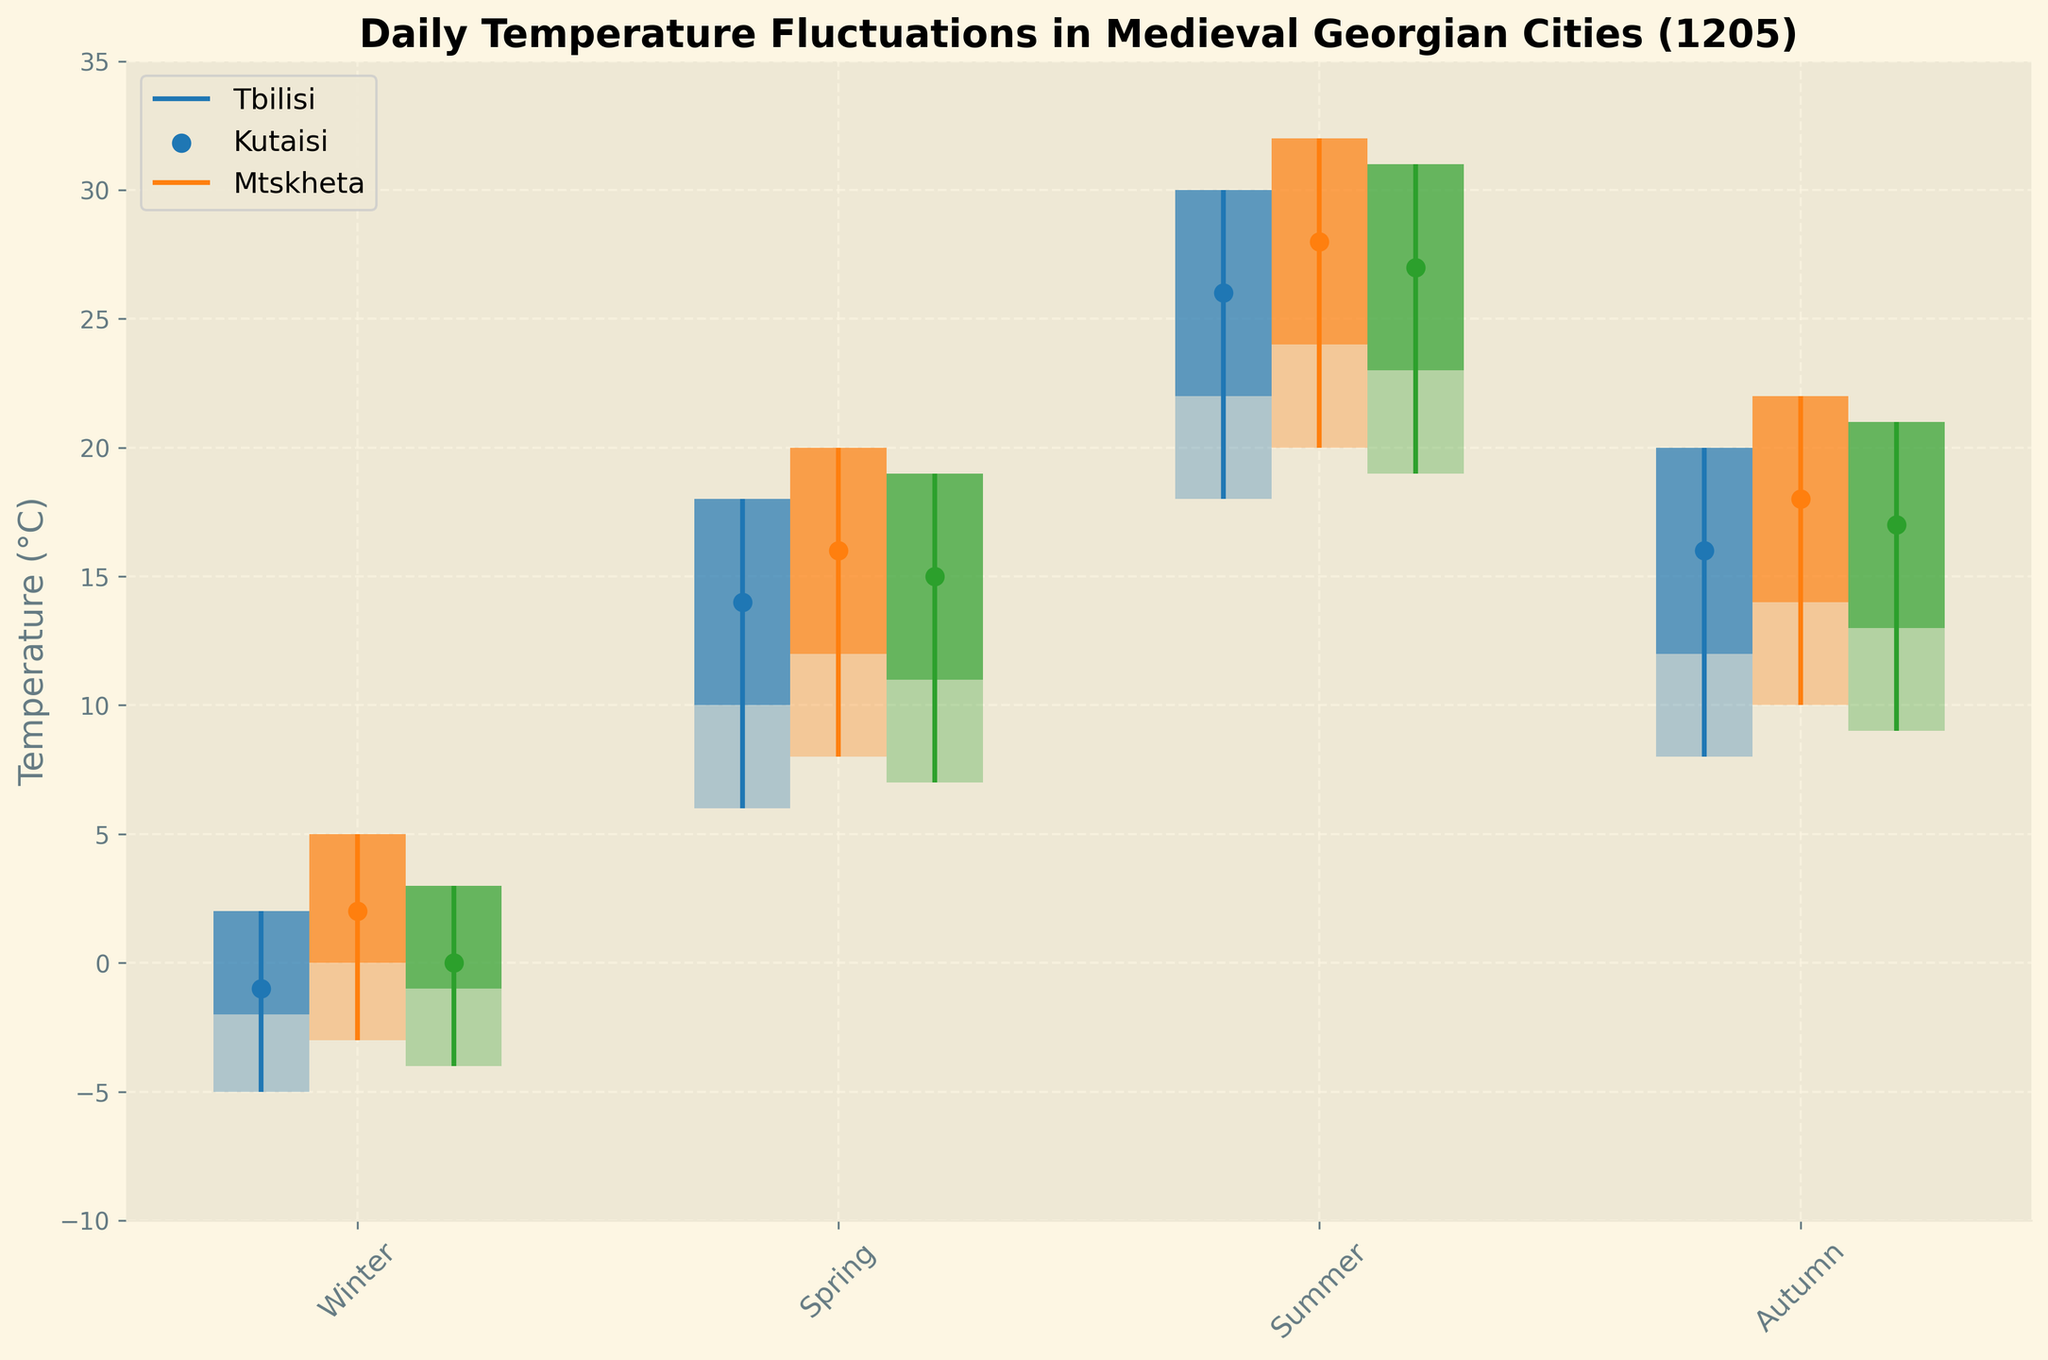what are the cities included in the figure? The figure includes three cities, as shown in the legend on the upper left corner: Tbilisi, Kutaisi, and Mtskheta.
Answer: Tbilisi, Kutaisi, Mtskheta What is the range of temperature fluctuations for Kutaisi in Summer? In Kutaisi during Summer, the high is 32°C and the low is 20°C. The range is calculated by subtracting the low from the high (32 - 20).
Answer: 12°C Which season has the lowest closing temperature for Tbilisi? By observing the closing temperatures for Tbilisi across all seasons (Winter: -1, Spring: 14, Summer: 26, Autumn: 16), Winter has the lowest closing temperature.
Answer: Winter Compare the highest temperatures recorded for each city in Spring. Which city recorded the highest temperature in Spring? In Spring, the highest temperatures for Tbilisi, Kutaisi, and Mtskheta are 18°C, 20°C, and 19°C respectively. Kutaisi recorded the highest temperature in Spring.
Answer: Kutaisi How do Tbilisi and Mtskheta's opening temperatures for Summer compare? The opening temperatures for Summer in Tbilisi and Mtskheta are 22°C and 23°C, respectively. Mtskheta's opening temperature is higher by 1°C.
Answer: Mtskheta Describe the visual representation of the closing temperature for Kutaisi in all seasons. The closing temperatures for Kutaisi in Winter, Spring, Summer, and Autumn are visually represented by a scatter plot with temperatures 2°C, 16°C, 28°C, and 18°C, respectively.
Answer: 2°C, 16°C, 28°C, 18°C What pattern can be observed in the temperature ranges across seasons for all cities? Observing the visual representation, temperature ranges (High - Low) for all cities increase from Winter (smallest range) to Summer (largest range) and then decrease again in Autumn.
Answer: Increase in Summer, decrease in Autumn 